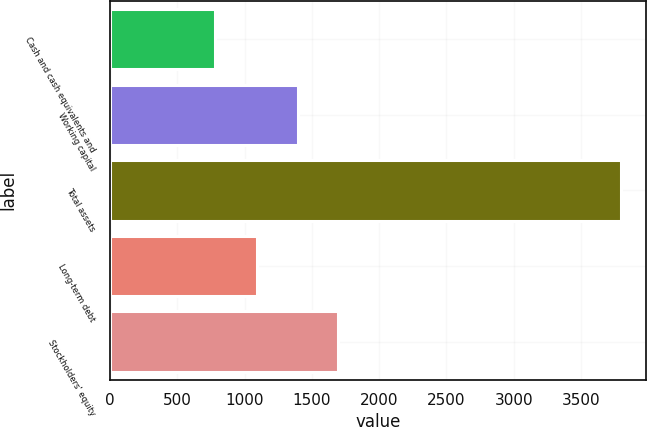Convert chart. <chart><loc_0><loc_0><loc_500><loc_500><bar_chart><fcel>Cash and cash equivalents and<fcel>Working capital<fcel>Total assets<fcel>Long-term debt<fcel>Stockholders' equity<nl><fcel>783<fcel>1394.3<fcel>3796<fcel>1093<fcel>1695.6<nl></chart> 